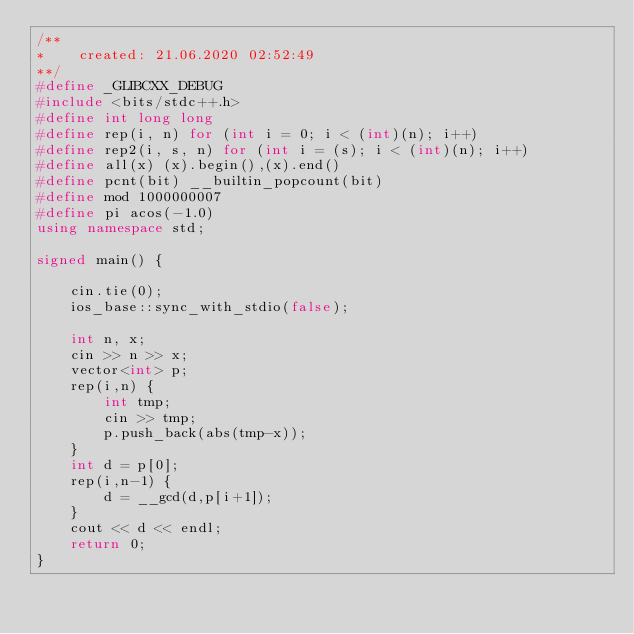<code> <loc_0><loc_0><loc_500><loc_500><_C++_>/**
*    created: 21.06.2020 02:52:49
**/
#define _GLIBCXX_DEBUG
#include <bits/stdc++.h>
#define int long long
#define rep(i, n) for (int i = 0; i < (int)(n); i++)
#define rep2(i, s, n) for (int i = (s); i < (int)(n); i++)
#define all(x) (x).begin(),(x).end()
#define pcnt(bit) __builtin_popcount(bit)
#define mod 1000000007
#define pi acos(-1.0)
using namespace std;

signed main() {

    cin.tie(0);
    ios_base::sync_with_stdio(false);

    int n, x;
    cin >> n >> x;
    vector<int> p;
    rep(i,n) {
        int tmp;
        cin >> tmp;
        p.push_back(abs(tmp-x));
    }
    int d = p[0];
    rep(i,n-1) {
        d = __gcd(d,p[i+1]);
    }
    cout << d << endl;
    return 0;
}</code> 